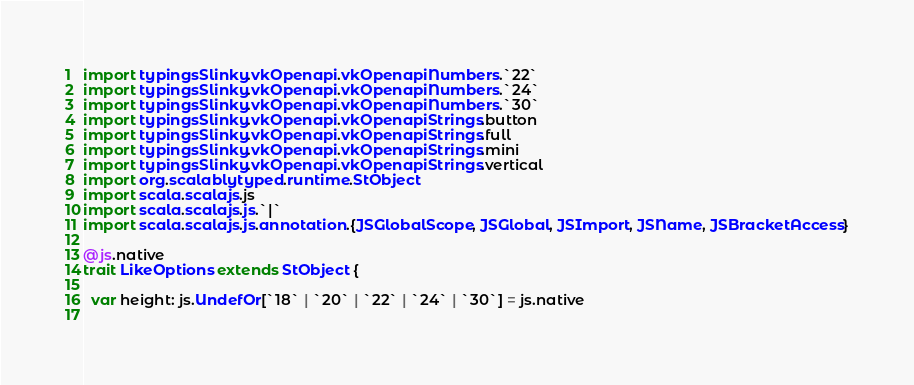<code> <loc_0><loc_0><loc_500><loc_500><_Scala_>import typingsSlinky.vkOpenapi.vkOpenapiNumbers.`22`
import typingsSlinky.vkOpenapi.vkOpenapiNumbers.`24`
import typingsSlinky.vkOpenapi.vkOpenapiNumbers.`30`
import typingsSlinky.vkOpenapi.vkOpenapiStrings.button
import typingsSlinky.vkOpenapi.vkOpenapiStrings.full
import typingsSlinky.vkOpenapi.vkOpenapiStrings.mini
import typingsSlinky.vkOpenapi.vkOpenapiStrings.vertical
import org.scalablytyped.runtime.StObject
import scala.scalajs.js
import scala.scalajs.js.`|`
import scala.scalajs.js.annotation.{JSGlobalScope, JSGlobal, JSImport, JSName, JSBracketAccess}

@js.native
trait LikeOptions extends StObject {
  
  var height: js.UndefOr[`18` | `20` | `22` | `24` | `30`] = js.native
  </code> 